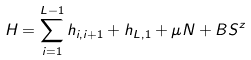<formula> <loc_0><loc_0><loc_500><loc_500>H = \sum _ { i = 1 } ^ { L - 1 } h _ { i , i + 1 } + h _ { L , 1 } + \mu N + B S ^ { z }</formula> 